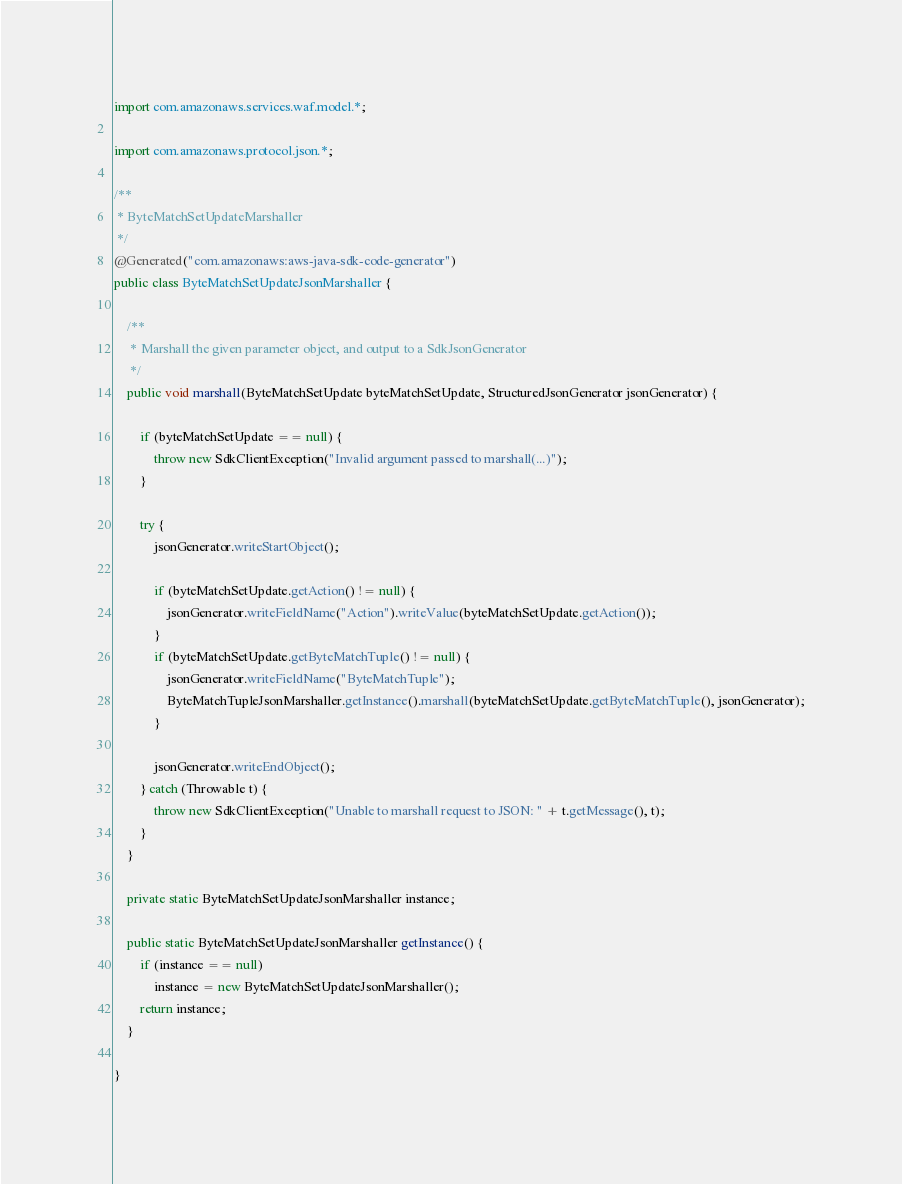Convert code to text. <code><loc_0><loc_0><loc_500><loc_500><_Java_>import com.amazonaws.services.waf.model.*;

import com.amazonaws.protocol.json.*;

/**
 * ByteMatchSetUpdateMarshaller
 */
@Generated("com.amazonaws:aws-java-sdk-code-generator")
public class ByteMatchSetUpdateJsonMarshaller {

    /**
     * Marshall the given parameter object, and output to a SdkJsonGenerator
     */
    public void marshall(ByteMatchSetUpdate byteMatchSetUpdate, StructuredJsonGenerator jsonGenerator) {

        if (byteMatchSetUpdate == null) {
            throw new SdkClientException("Invalid argument passed to marshall(...)");
        }

        try {
            jsonGenerator.writeStartObject();

            if (byteMatchSetUpdate.getAction() != null) {
                jsonGenerator.writeFieldName("Action").writeValue(byteMatchSetUpdate.getAction());
            }
            if (byteMatchSetUpdate.getByteMatchTuple() != null) {
                jsonGenerator.writeFieldName("ByteMatchTuple");
                ByteMatchTupleJsonMarshaller.getInstance().marshall(byteMatchSetUpdate.getByteMatchTuple(), jsonGenerator);
            }

            jsonGenerator.writeEndObject();
        } catch (Throwable t) {
            throw new SdkClientException("Unable to marshall request to JSON: " + t.getMessage(), t);
        }
    }

    private static ByteMatchSetUpdateJsonMarshaller instance;

    public static ByteMatchSetUpdateJsonMarshaller getInstance() {
        if (instance == null)
            instance = new ByteMatchSetUpdateJsonMarshaller();
        return instance;
    }

}
</code> 